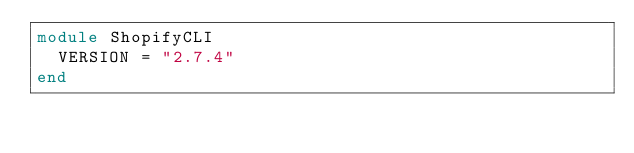Convert code to text. <code><loc_0><loc_0><loc_500><loc_500><_Ruby_>module ShopifyCLI
  VERSION = "2.7.4"
end
</code> 